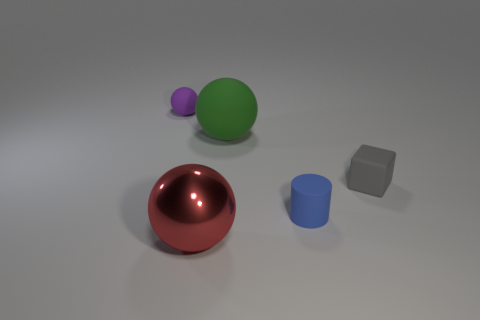What can you infer about the size of these objects in relation to each other? Based on their relative proportions in the image, the red sphere appears the largest, followed by the green ball which is slightly smaller, then the blue cylinder, and finally the gray cube which is the smallest of all the objects. Their assorted sizes offer a sense of scale and can give clues about how they might be used or interacted with in real-life settings.  What does the arrangement of these objects suggest to you? The objects are spaced apart in a deliberate manner that feels neither random nor overly structured, creating a balanced composition. It might be designed to display variety – in shape, size, and color – without any particular object dominating the scene. This kind of arrangement could be useful in a demonstration or educational context to showcase differences in physical properties. 